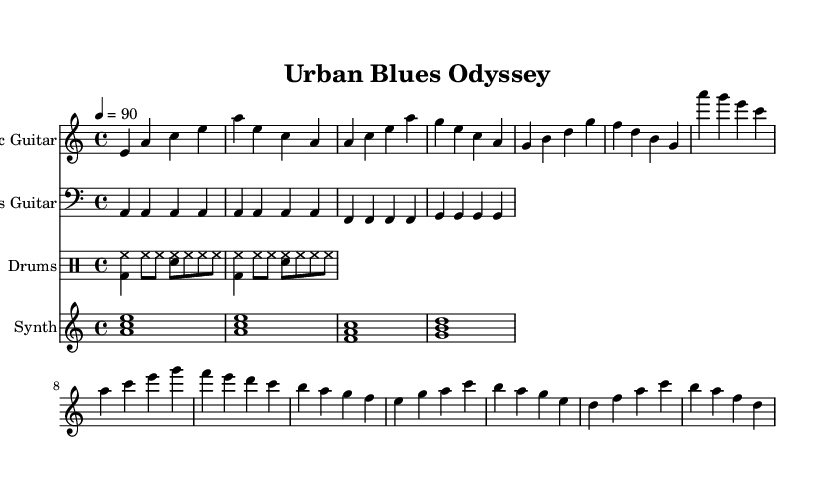What is the key signature of this music? The key signature is A minor, which has no sharps or flats indicated. In the sheet music, since it uses the 'a' note primarily and conforms to the signatures associated with A minor, the key is A minor.
Answer: A minor What is the time signature of this piece? The time signature is 4/4, which means there are four beats in each measure and a quarter note receives one beat. This is indicated in the beginning of the sheet music right after the clef.
Answer: 4/4 What is the tempo marking for this composition? The tempo marking is set to 90 beats per minute, indicated by the 'tempo 4 = 90' at the beginning of the music. This provides the speed for how the piece is to be played.
Answer: 90 How many measures are in the verse section? The verse section contains four measures, which can be counted sequentially in the provided music line from the start of the verse until it transitions to the chorus.
Answer: 4 What is the primary instrument featured in this piece? The primary instrument featured in this piece is the electric guitar, as indicated by the instrument name specified at the start of the electric guitar staff.
Answer: Electric Guitar What genre does this music belong to? This music belongs to the Electric Blues genre, characterized by its modern fusion of blues elements with hip-hop beats and rap-inspired lyrics, as suggested by the overall style and combination of instruments present.
Answer: Electric Blues What type of chord progression is used in this piece? The chord progression primarily utilizes a I-IV-V pattern common in blues music, as seen in the phrases of the guitar and bass parts which revolve around A, D, and E chords in the context of A minor.
Answer: I-IV-V 